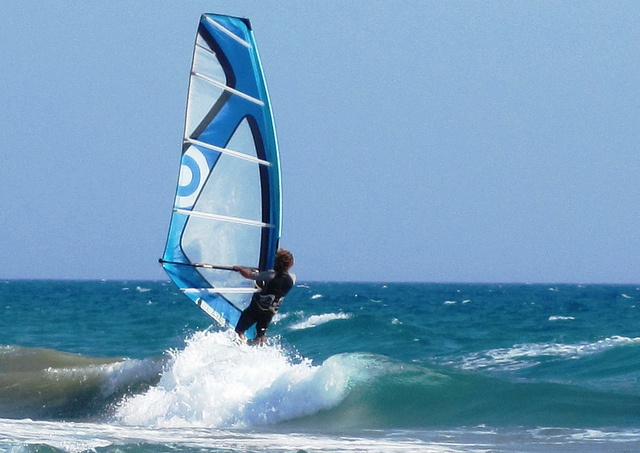Describe the objects in this image and their specific colors. I can see boat in lightblue, blue, and lightgray tones, people in lightblue, black, gray, navy, and darkgray tones, and surfboard in lightblue, white, gray, and darkgray tones in this image. 